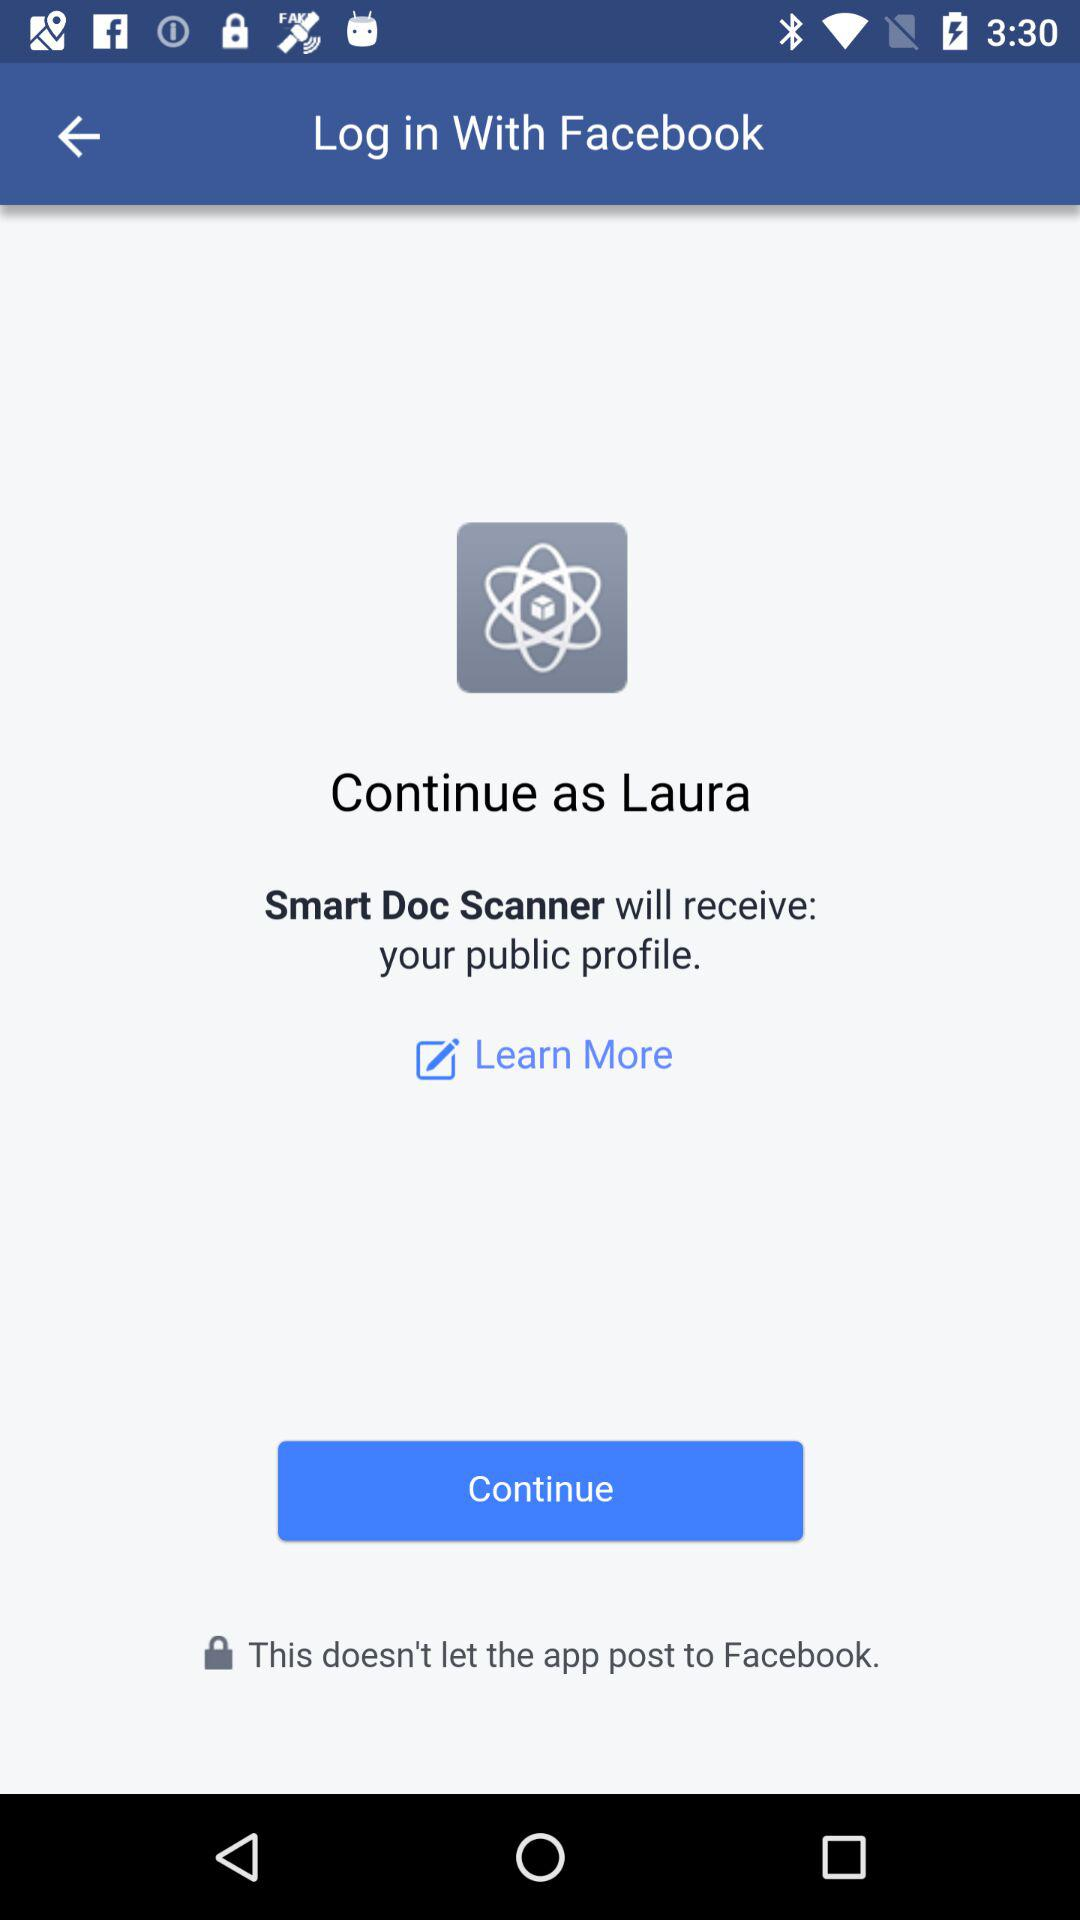What account can be used to continue? The account that can be used to continue is "Facebook". 